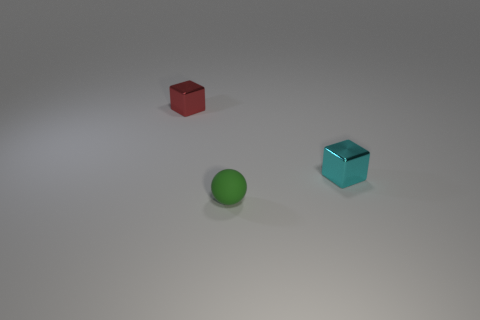Subtract all cyan blocks. How many blocks are left? 1 Add 2 yellow matte cubes. How many objects exist? 5 Subtract all spheres. How many objects are left? 2 Add 2 large blue metallic cylinders. How many large blue metallic cylinders exist? 2 Subtract 0 green cylinders. How many objects are left? 3 Subtract 1 spheres. How many spheres are left? 0 Subtract all yellow cubes. Subtract all red balls. How many cubes are left? 2 Subtract all blue balls. How many blue cubes are left? 0 Subtract all green things. Subtract all red metal objects. How many objects are left? 1 Add 1 green spheres. How many green spheres are left? 2 